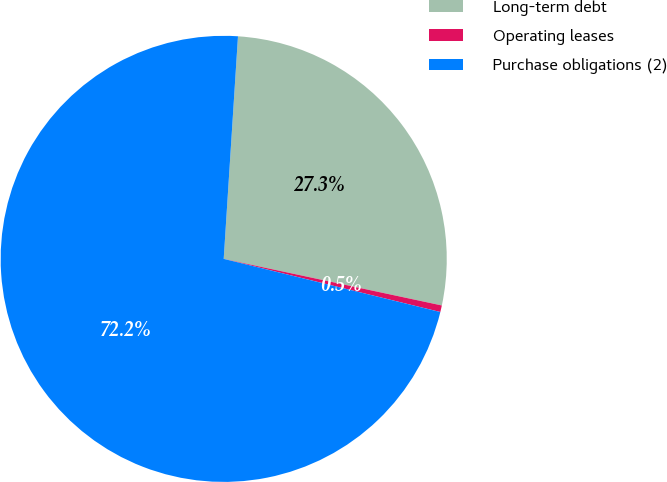<chart> <loc_0><loc_0><loc_500><loc_500><pie_chart><fcel>Long-term debt<fcel>Operating leases<fcel>Purchase obligations (2)<nl><fcel>27.33%<fcel>0.48%<fcel>72.19%<nl></chart> 